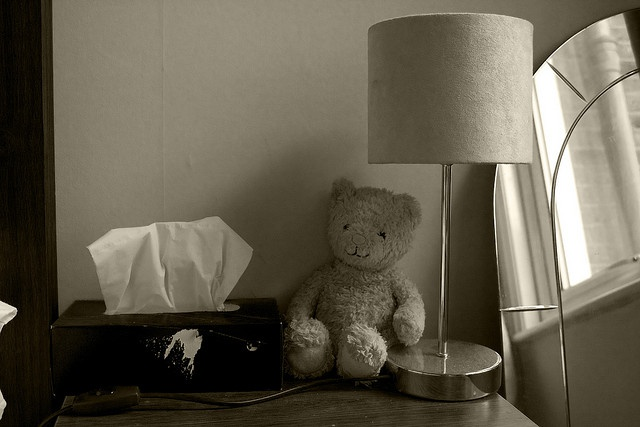Describe the objects in this image and their specific colors. I can see a teddy bear in black and gray tones in this image. 